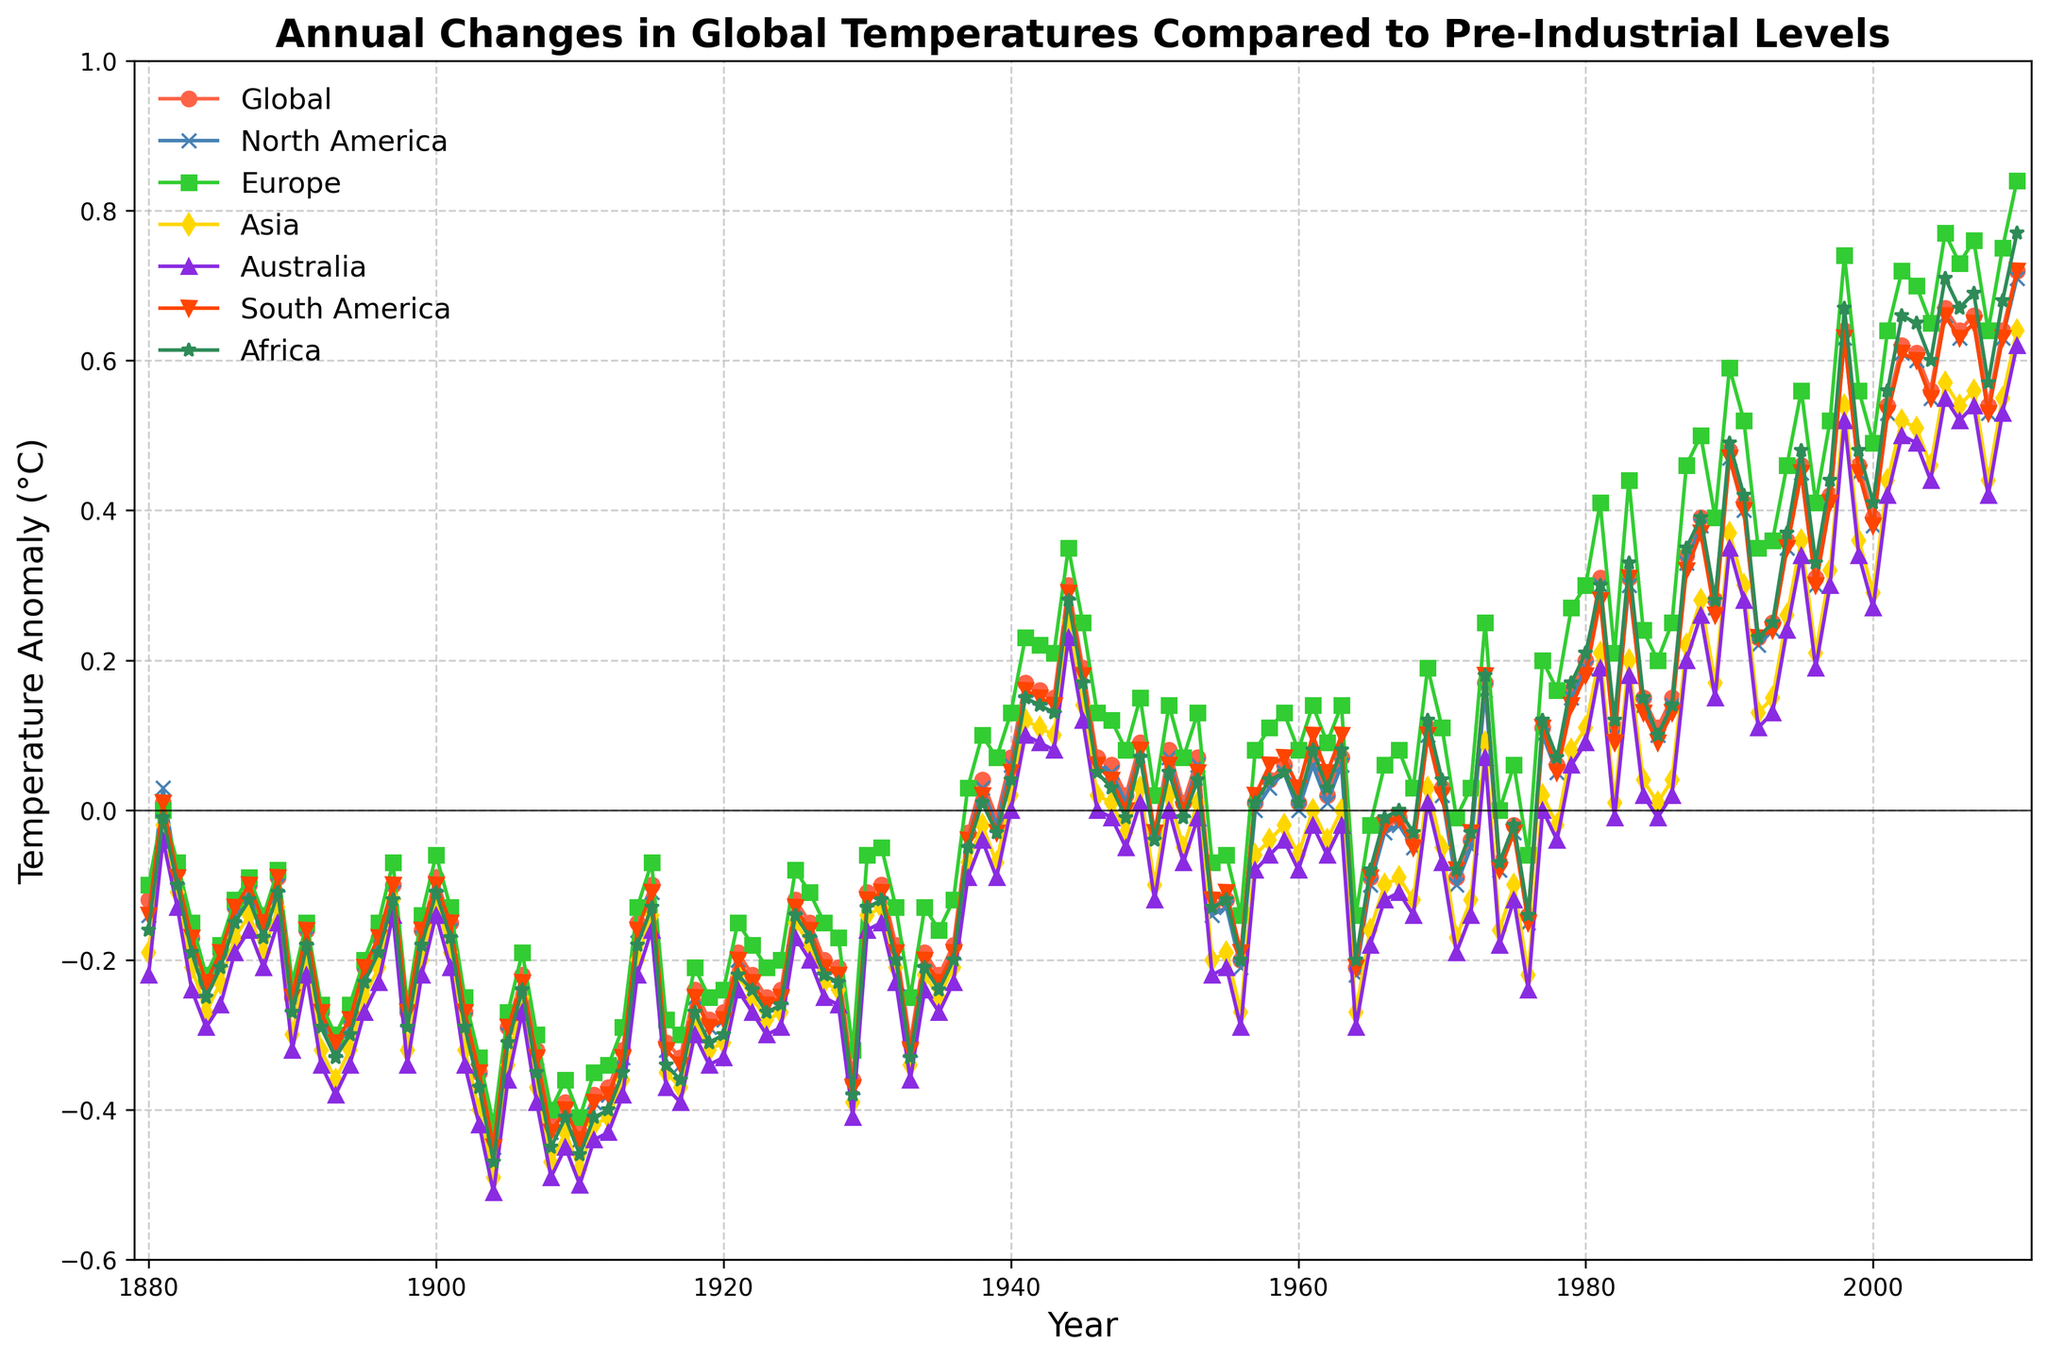What is the highest global temperature anomaly recorded in the data? To find the highest global temperature anomaly, look for the highest point on the line representing the global temperature anomaly. It reaches its peak in 2010 with a value of 0.72°C.
Answer: 0.72°C Which region showed the largest temperature anomaly in any year, and what was the value? The region with the largest recorded temperature anomaly can be identified by inspecting the highest point across all regional lines. It occurs in Asia in 2010, peaking at 0.84°C.
Answer: Asia, 0.84°C During which year did Europe have its highest temperature anomaly, and what was the value? Trace the line representing Europe to find its highest point. Europe's highest temperature anomaly was in 2010 with a value of 0.84°C.
Answer: 2010, 0.84°C What is the difference between the global temperature anomalies in 1900 and 2010? Find the global temperature anomaly for the years 1900 and 2010. In 1900, it was -0.09°C, and in 2010, it was 0.72°C. The difference is 0.72°C - (-0.09°C) = 0.81°C.
Answer: 0.81°C In what year did Africa have a zero temperature anomaly, and what was the corresponding global temperature anomaly? Locate the year on the Africa line where the temperature anomaly is zero. This occurs in 1881. The corresponding global temperature anomaly in 1881 is 0.01°C.
Answer: 1881, 0.01°C Which regions showed a temperature anomaly greater than that of the global average in 2005, and what were their values? Check the values of temperature anomalies in 2005 for each region and compare them with the global average of 0.67°C. Asia (0.77°C) and Europe (0.77°C) had higher anomalies.
Answer: Asia (0.77°C), Europe (0.77°C) Did North America or Australia have a higher temperature anomaly in 1944, and by how much? Compare the anomalies for North America and Australia in 1944. North America had 0.29°C and Australia had 0.25°C. The difference is 0.29°C - 0.25°C = 0.04°C.
Answer: North America by 0.04°C Which region's temperature anomaly changed the most between 1975 and 1976, and what is the change? Calculate the difference in temperature anomalies between 1975 and 1976 for each region. The largest change is in Africa, from -0.03°C in 1975 to -0.15°C in 1976, a change of -0.12°C.
Answer: Africa, -0.12°C What is the average global temperature anomaly for the decade from 1990 to 2000? Sum the global temperature anomalies from 1990 to 2000 and divide by the number of years. (0.48+0.41+0.23+0.25+0.36+0.46+0.31+0.42+0.64+0.46+0.39)/11 = 0.39°C.
Answer: 0.39°C Which region had a positive temperature anomaly first, and in what year did this occur? Identify the first year each region's temperature anomaly turns positive. North America and South America both show a positive anomaly first in 1881.
Answer: North America and South America, 1881 